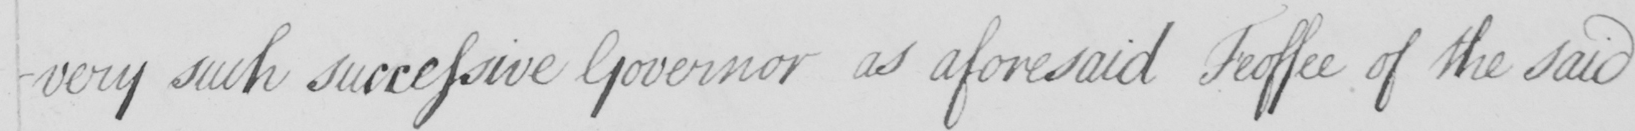What does this handwritten line say? -very such successive Governor as aforesaid Feoffee of the said 